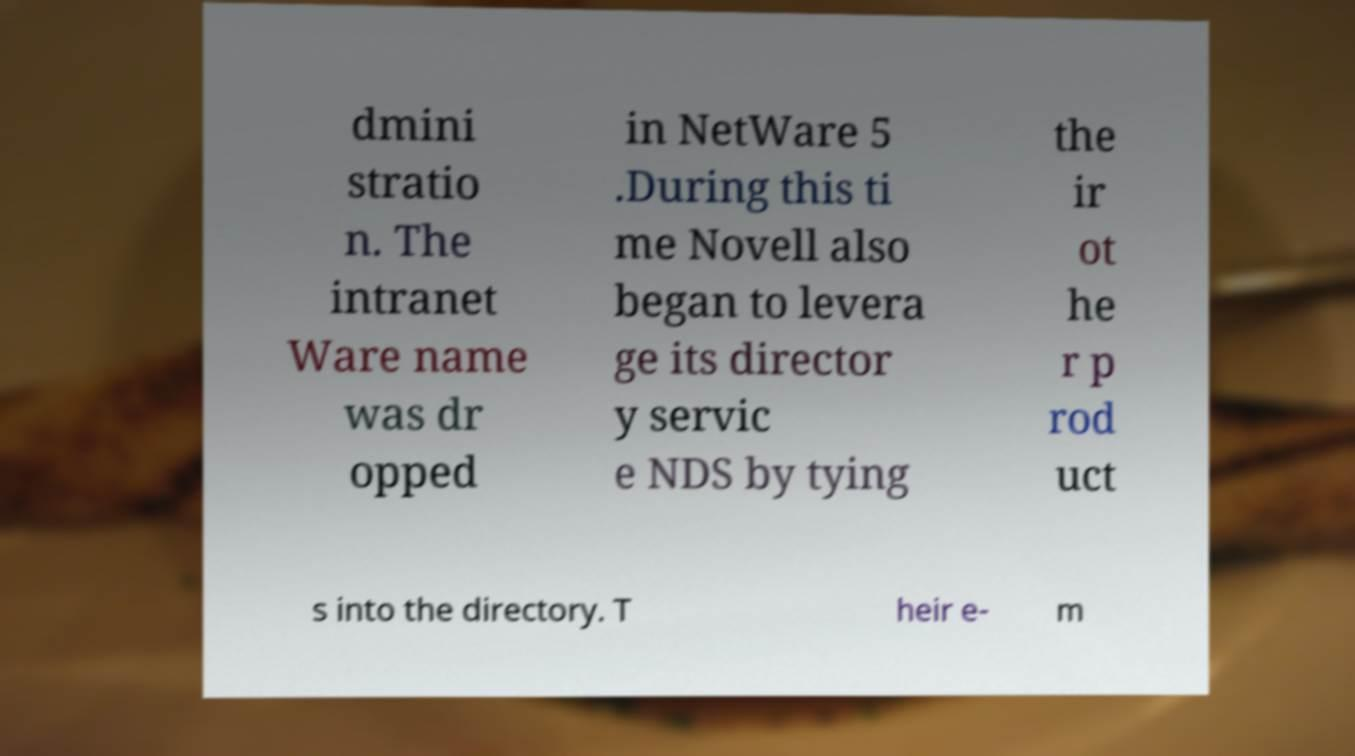Could you assist in decoding the text presented in this image and type it out clearly? dmini stratio n. The intranet Ware name was dr opped in NetWare 5 .During this ti me Novell also began to levera ge its director y servic e NDS by tying the ir ot he r p rod uct s into the directory. T heir e- m 